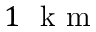<formula> <loc_0><loc_0><loc_500><loc_500>1 k m</formula> 